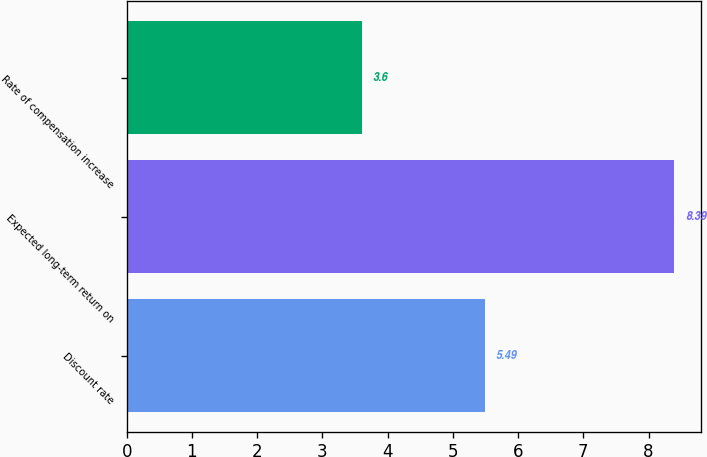<chart> <loc_0><loc_0><loc_500><loc_500><bar_chart><fcel>Discount rate<fcel>Expected long-term return on<fcel>Rate of compensation increase<nl><fcel>5.49<fcel>8.39<fcel>3.6<nl></chart> 